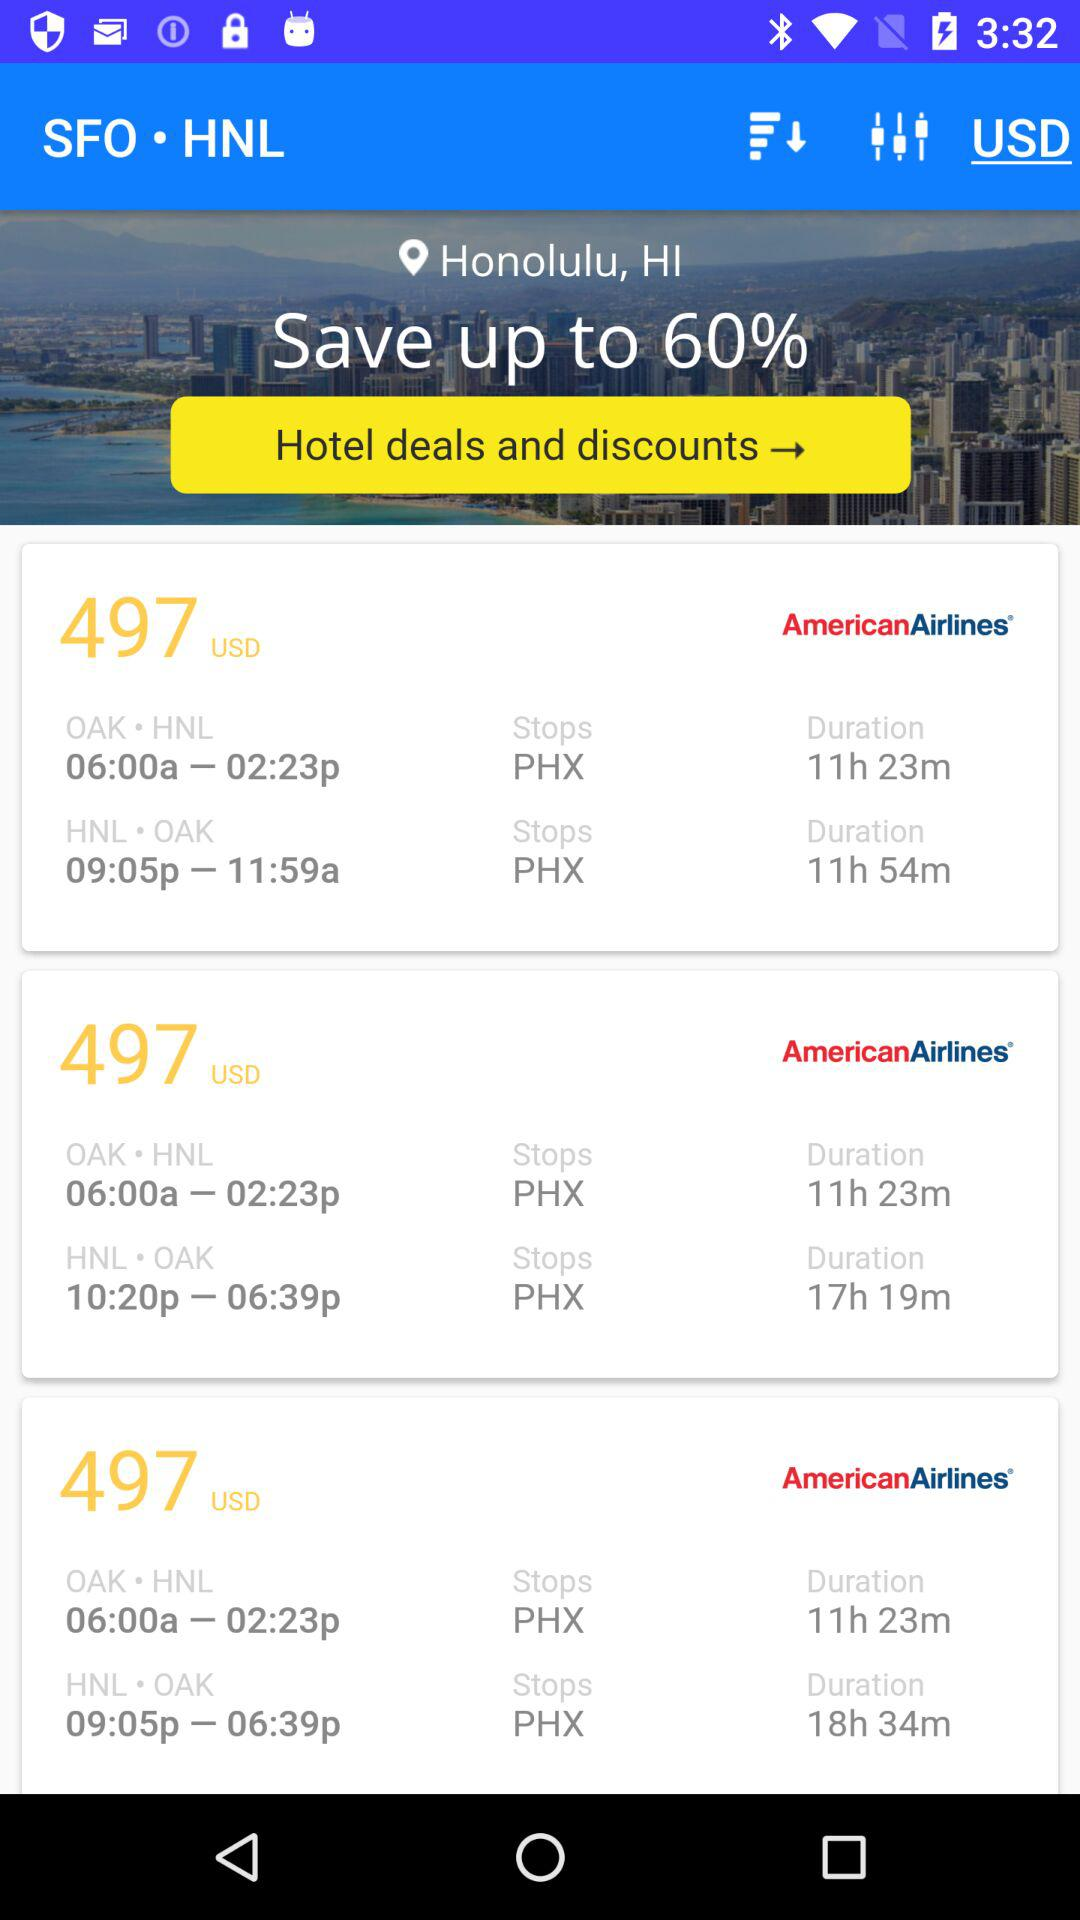What's the currency? The currency is the USD. 